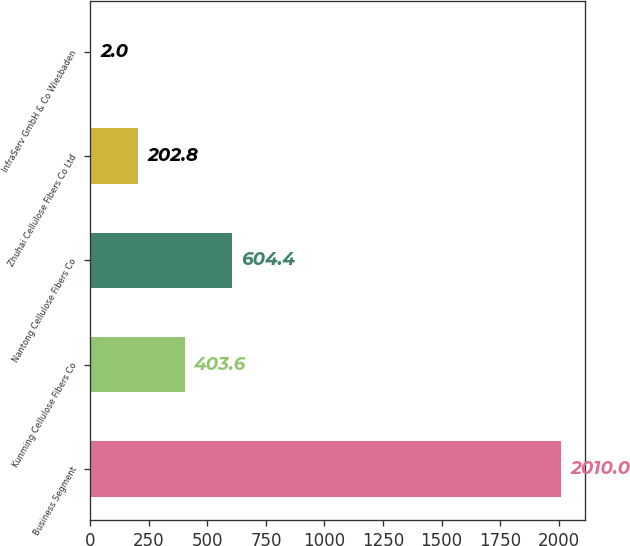Convert chart. <chart><loc_0><loc_0><loc_500><loc_500><bar_chart><fcel>Business Segment<fcel>Kunming Cellulose Fibers Co<fcel>Nantong Cellulose Fibers Co<fcel>Zhuhai Cellulose Fibers Co Ltd<fcel>InfraServ GmbH & Co Wiesbaden<nl><fcel>2010<fcel>403.6<fcel>604.4<fcel>202.8<fcel>2<nl></chart> 